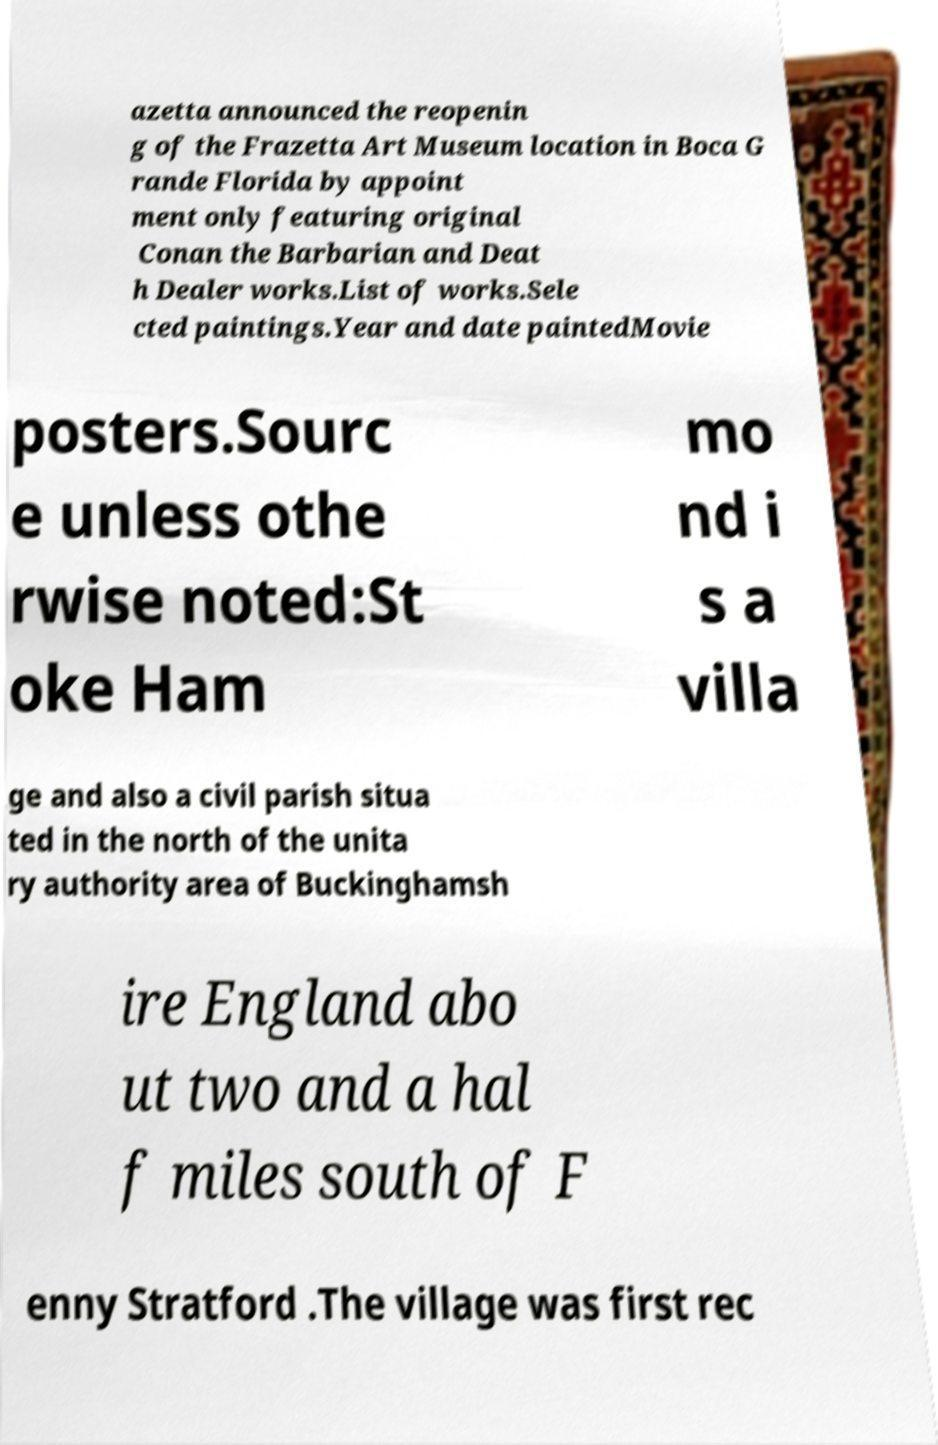Could you extract and type out the text from this image? azetta announced the reopenin g of the Frazetta Art Museum location in Boca G rande Florida by appoint ment only featuring original Conan the Barbarian and Deat h Dealer works.List of works.Sele cted paintings.Year and date paintedMovie posters.Sourc e unless othe rwise noted:St oke Ham mo nd i s a villa ge and also a civil parish situa ted in the north of the unita ry authority area of Buckinghamsh ire England abo ut two and a hal f miles south of F enny Stratford .The village was first rec 